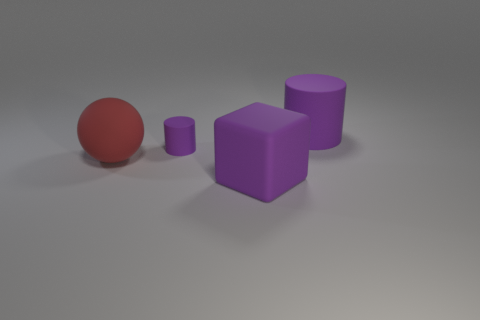Is there a big rubber block behind the big purple rubber object behind the purple matte thing that is in front of the red ball?
Give a very brief answer. No. What shape is the purple thing that is the same size as the rubber block?
Provide a succinct answer. Cylinder. The large thing that is the same shape as the tiny purple matte object is what color?
Your answer should be very brief. Purple. What number of objects are purple metal objects or cylinders?
Provide a short and direct response. 2. There is a purple matte thing that is to the left of the big purple matte cube; does it have the same shape as the object on the left side of the small purple object?
Keep it short and to the point. No. What is the shape of the large purple rubber object on the left side of the big purple cylinder?
Make the answer very short. Cube. Are there an equal number of red matte balls in front of the big cube and big red spheres on the left side of the rubber ball?
Provide a short and direct response. Yes. How many objects are tiny purple objects or tiny purple cylinders that are to the left of the large rubber block?
Your answer should be compact. 1. The object that is both in front of the small purple matte cylinder and to the right of the large red thing has what shape?
Your answer should be very brief. Cube. There is a large object behind the purple matte cylinder that is left of the rubber cube; what is its material?
Offer a terse response. Rubber. 